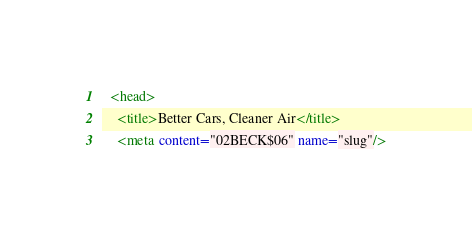Convert code to text. <code><loc_0><loc_0><loc_500><loc_500><_XML_>  <head>
    <title>Better Cars, Cleaner Air</title>
    <meta content="02BECK$06" name="slug"/></code> 